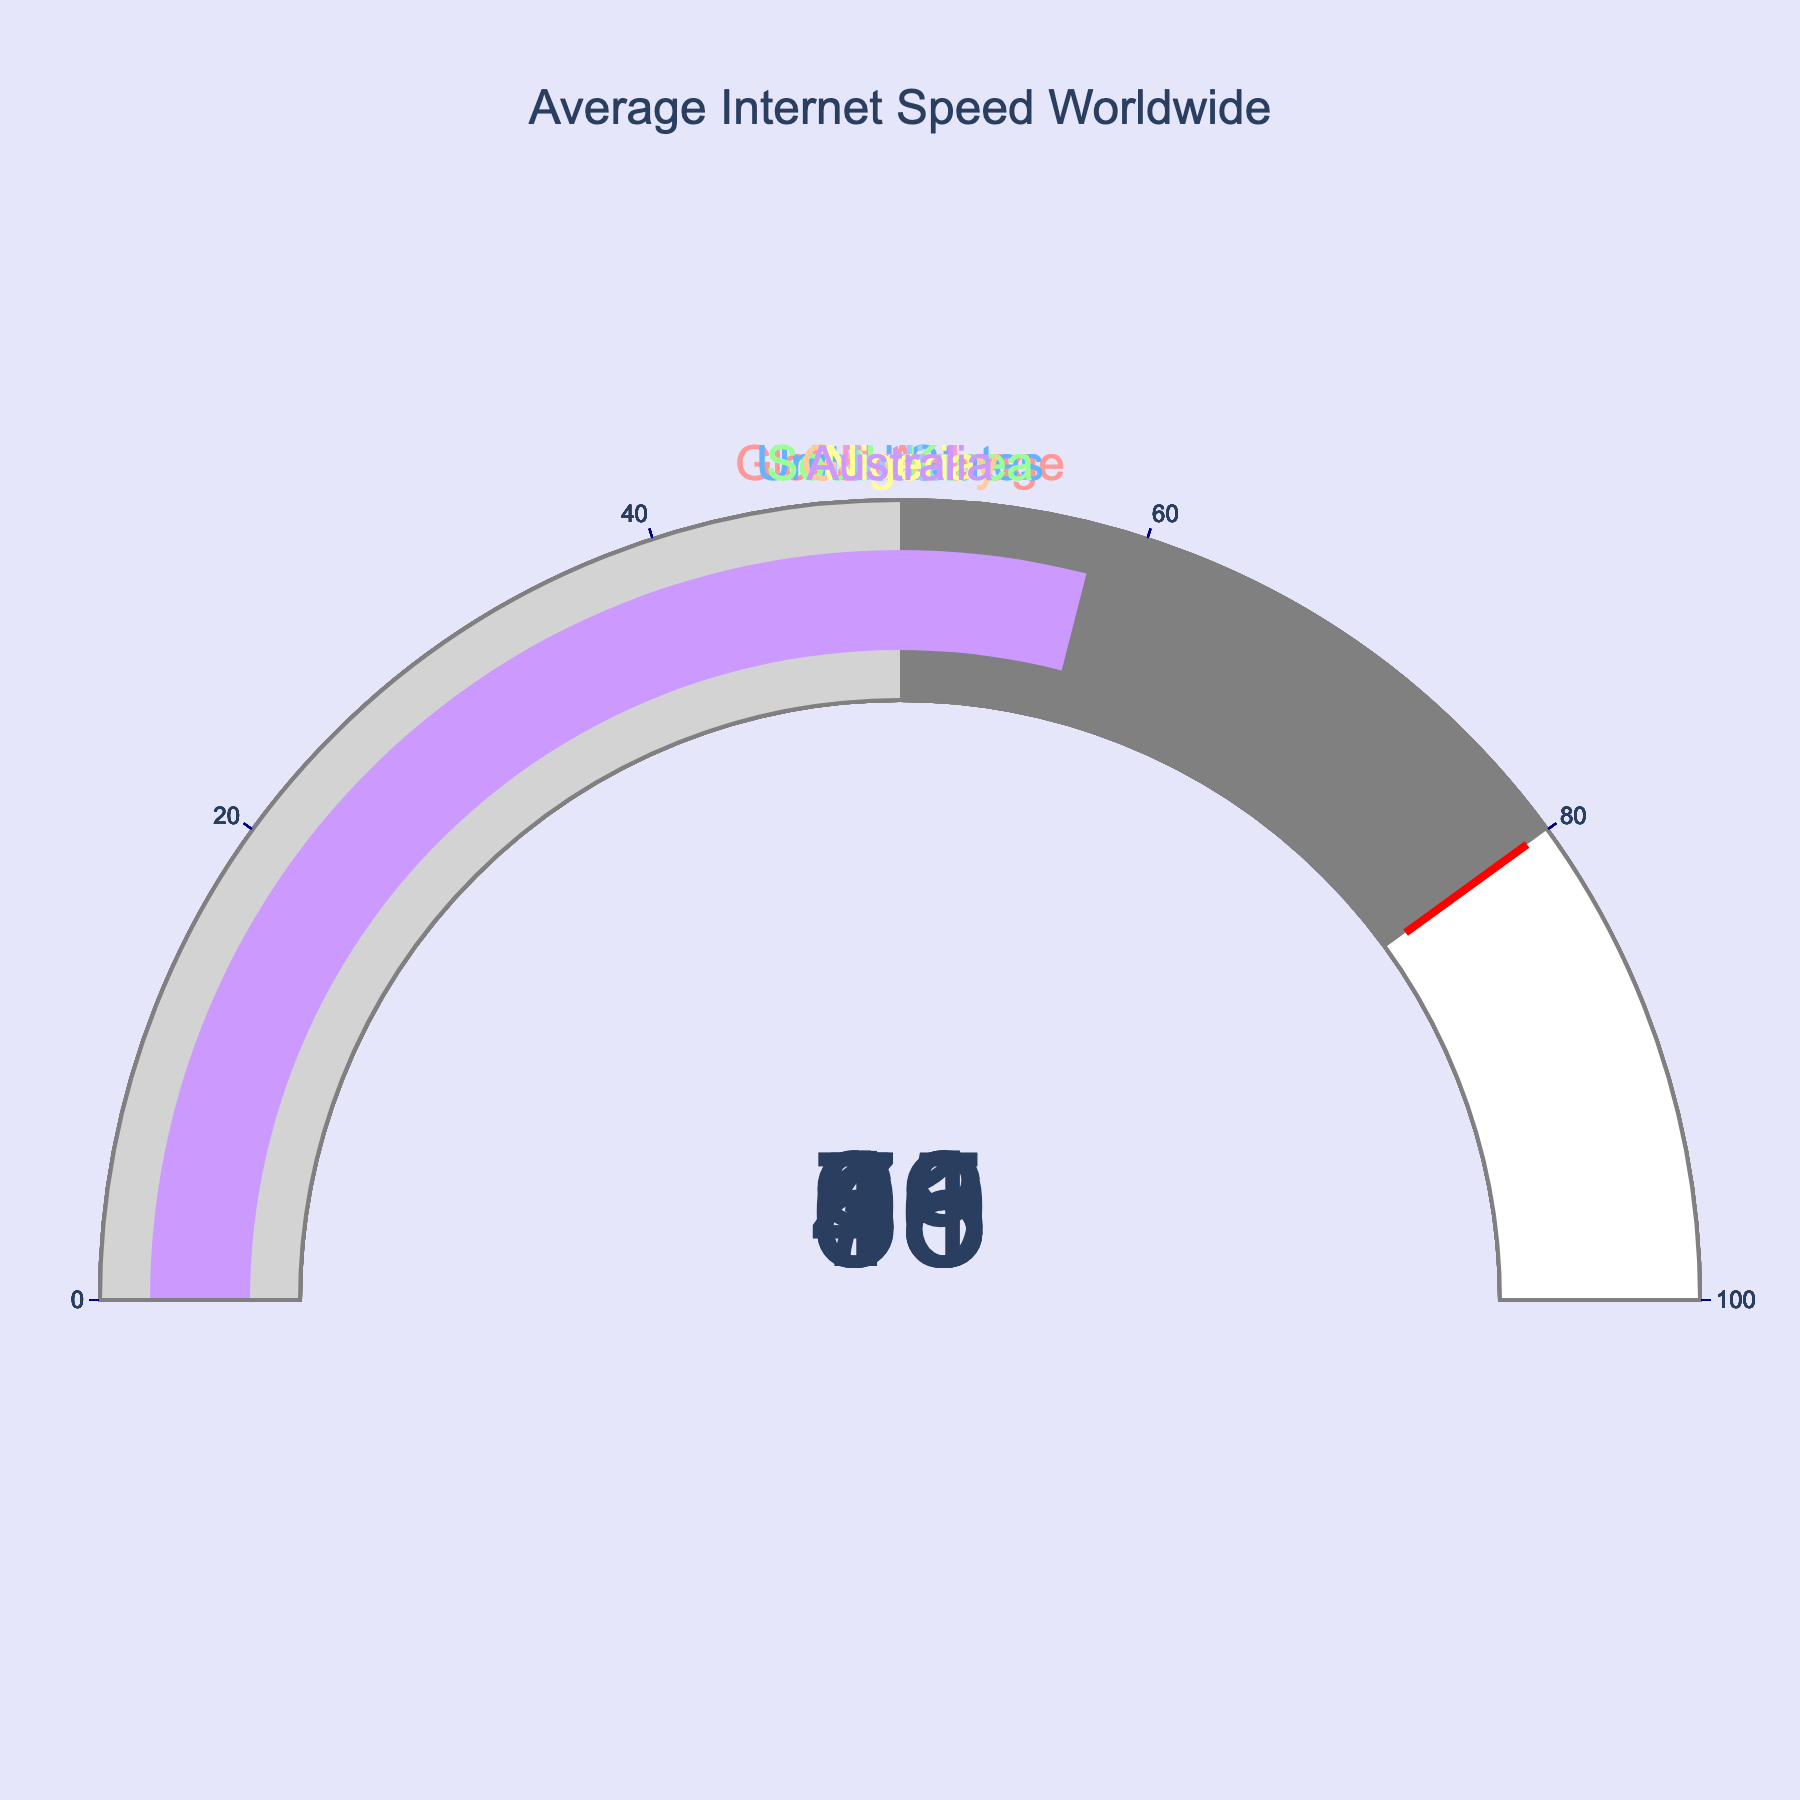What's the title of the figure? The title is usually displayed at the top center of the figure.
Answer: Average Internet Speed Worldwide How many countries' data are shown in the figure? By counting the number of gauge plots or noting the unique titles on each gauge.
Answer: 8 Which country has the highest average internet speed percentage? Look for the gauge with the highest number.
Answer: South Korea Which country has the lowest average internet speed percentage? Look for the gauge with the lowest number.
Answer: Nigeria What's the average internet speed percentage of Germany? Identify the gauge labeled "Germany" and read the number shown.
Answer: 68 How does the average speed percentage in the United States compare to Brazil? Identify the gauges for both the United States and Brazil and compare the numbers.
Answer: The United States is higher (76% vs 39%) What's the difference in average speed percentage between Australia and India? Subtract the percentage of India from that of Australia (58 - 31).
Answer: 27 What's the range of average internet speed percentages shown in the figure? The range is the difference between the highest and lowest values (93 - 18).
Answer: 75 What is the threshold value highlighted in the gauge chart? It is the value marked by a special indicator (typically in red) on each gauge.
Answer: 80 Do more countries have an average speed percentage below 50% or above 50%? Count the countries in each category.
Answer: Below 50% 